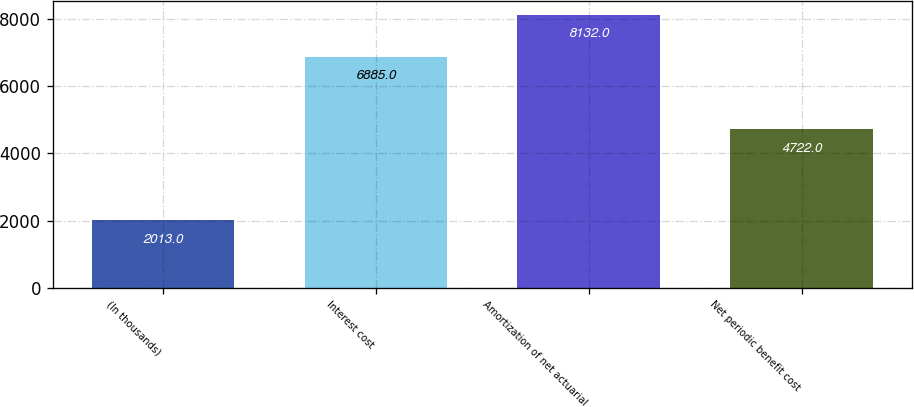Convert chart. <chart><loc_0><loc_0><loc_500><loc_500><bar_chart><fcel>(In thousands)<fcel>Interest cost<fcel>Amortization of net actuarial<fcel>Net periodic benefit cost<nl><fcel>2013<fcel>6885<fcel>8132<fcel>4722<nl></chart> 